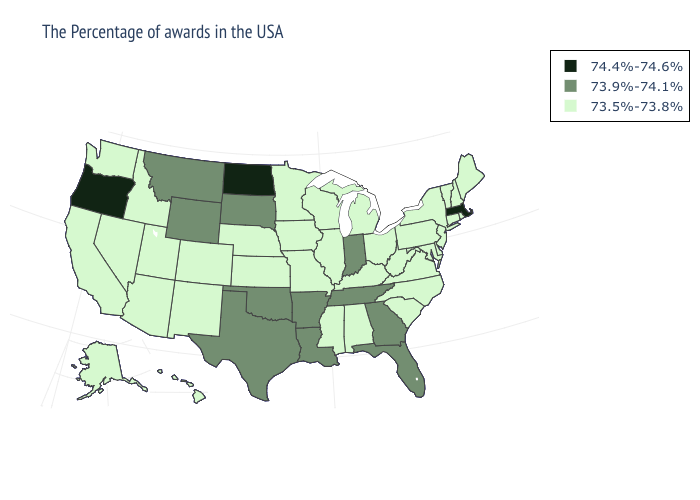Among the states that border Kansas , which have the lowest value?
Keep it brief. Missouri, Nebraska, Colorado. How many symbols are there in the legend?
Be succinct. 3. Among the states that border Kentucky , does Tennessee have the lowest value?
Give a very brief answer. No. Does California have a higher value than Ohio?
Keep it brief. No. Does Alaska have the highest value in the USA?
Keep it brief. No. What is the value of Alaska?
Give a very brief answer. 73.5%-73.8%. How many symbols are there in the legend?
Be succinct. 3. Name the states that have a value in the range 73.9%-74.1%?
Give a very brief answer. Florida, Georgia, Indiana, Tennessee, Louisiana, Arkansas, Oklahoma, Texas, South Dakota, Wyoming, Montana. Which states have the lowest value in the USA?
Concise answer only. Maine, Rhode Island, New Hampshire, Vermont, Connecticut, New York, New Jersey, Delaware, Maryland, Pennsylvania, Virginia, North Carolina, South Carolina, West Virginia, Ohio, Michigan, Kentucky, Alabama, Wisconsin, Illinois, Mississippi, Missouri, Minnesota, Iowa, Kansas, Nebraska, Colorado, New Mexico, Utah, Arizona, Idaho, Nevada, California, Washington, Alaska, Hawaii. What is the value of Delaware?
Quick response, please. 73.5%-73.8%. Which states have the lowest value in the South?
Give a very brief answer. Delaware, Maryland, Virginia, North Carolina, South Carolina, West Virginia, Kentucky, Alabama, Mississippi. Does South Dakota have the highest value in the USA?
Concise answer only. No. Does Iowa have the lowest value in the USA?
Give a very brief answer. Yes. What is the value of Georgia?
Be succinct. 73.9%-74.1%. Among the states that border Florida , which have the highest value?
Concise answer only. Georgia. 